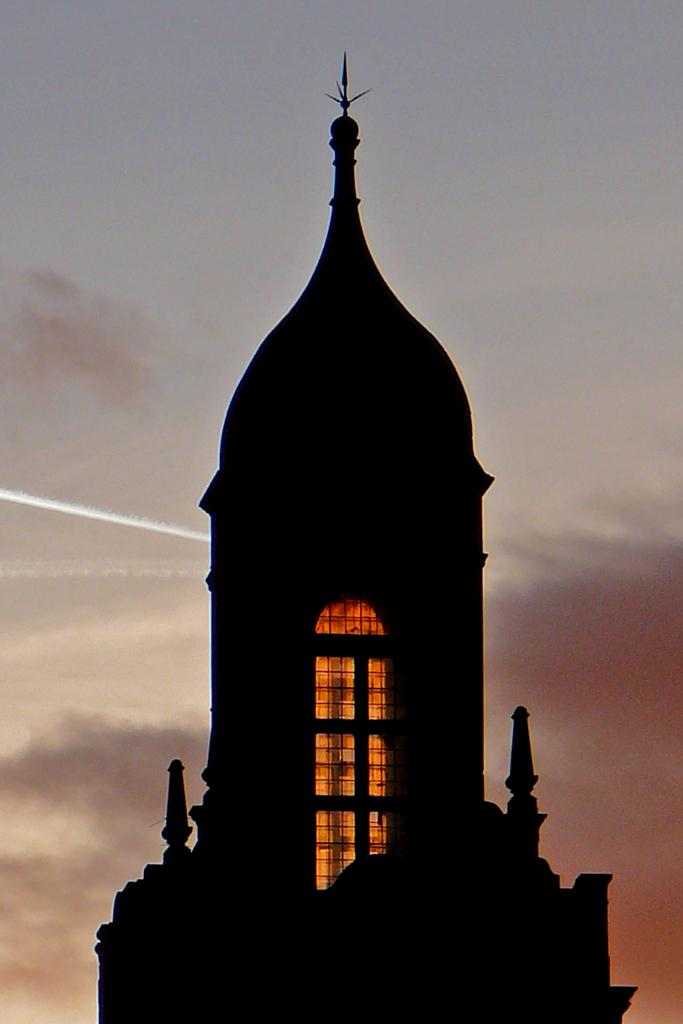What is the main structure in the image? There is a building in the image. What feature can be seen on the building? The building has windows. What can be seen in the distance in the image? The sky is visible in the background of the image. Can you tell if the building is occupied or not? Yes, there is light inside the building, which suggests that it is occupied. What type of muscle is visible on the building in the image? There are no muscles present on the building in the image; it is a structure made of materials like concrete, steel, or wood. 